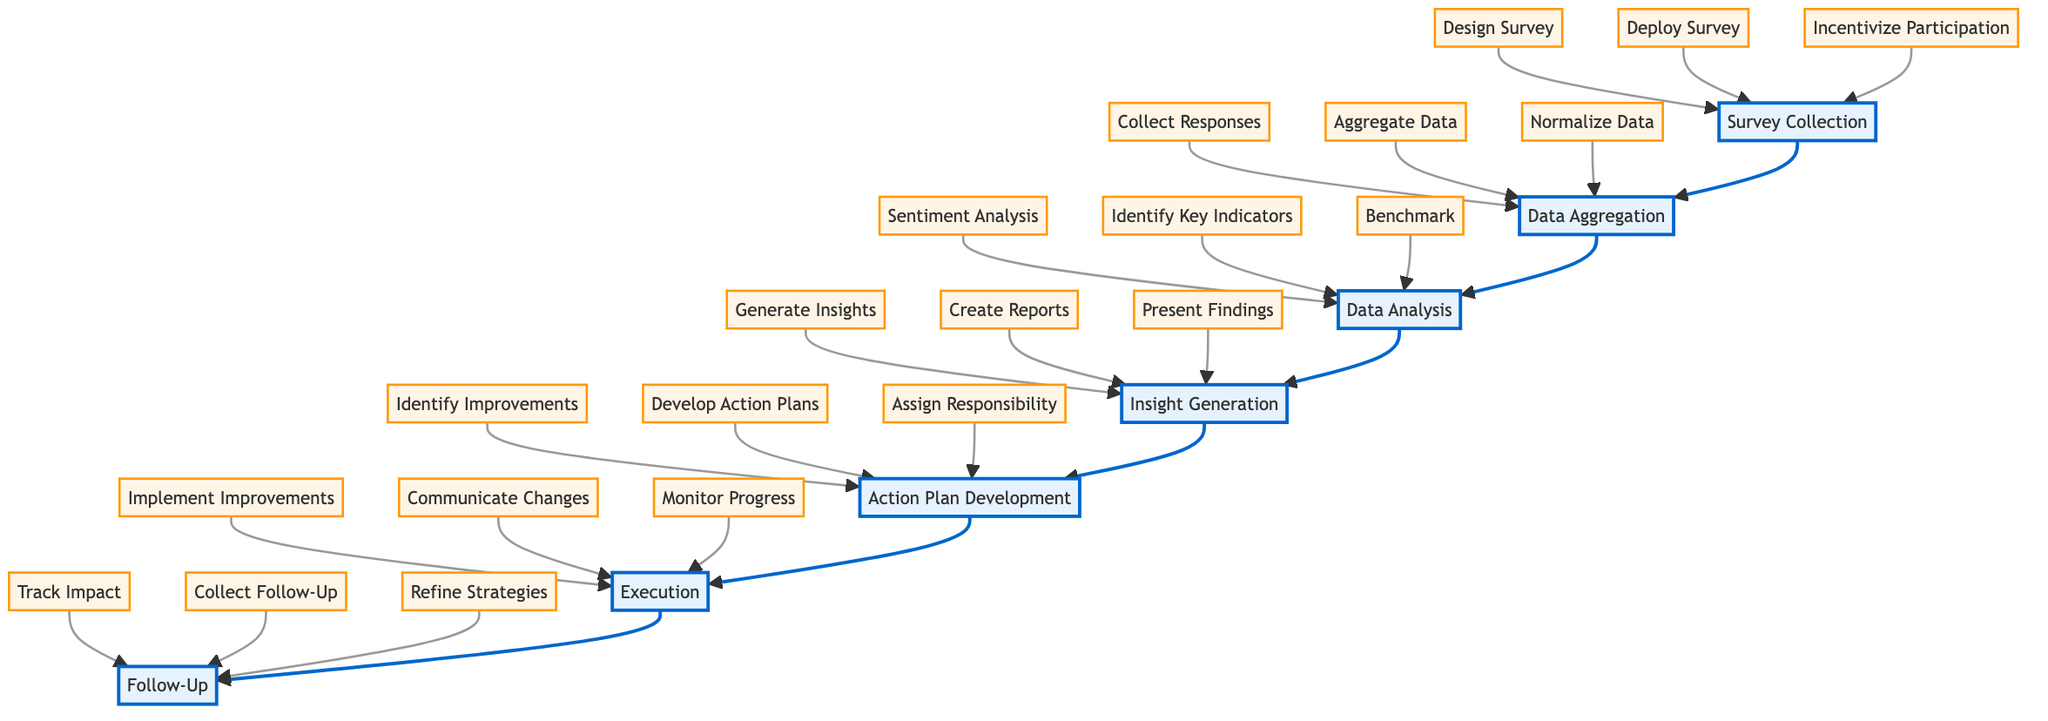What is the first step in the Tenant Satisfaction Improvement process? The diagram indicates that the first step is "Survey Collection," as it is positioned at the bottom of the flow chart and points towards the next step.
Answer: Survey Collection How many components are involved in the "Data Analysis" step? In the diagram, the "Data Analysis" step has three components listed below it: "Perform Sentiment Analysis," "Identify Key Satisfaction Indicators," and "Benchmark Against Industry Standards." Therefore, there are three components.
Answer: 3 What step follows "Insight Generation"? The diagram shows an upward flow where "Insight Generation" is directly connected to "Action Plan Development," indicating that "Action Plan Development" follows "Insight Generation."
Answer: Action Plan Development What action must be taken after insights have been generated? After generating insights, the next required action is to create reports and dashboards and present findings to the management team, which happens in the "Action Plan Development" step. Therefore, we must develop action plans based on the insights generated.
Answer: Develop Action Plans Which step includes monitoring implementation progress? The diagram specifies that the "Execution" step includes monitoring the implementation progress, as it is listed as one of the components under "Execution."
Answer: Execution What is the last step in the Tenant Satisfaction Improvement process? The diagram indicates that the last step is "Follow-Up," which is positioned at the top of the flowchart, indicating it is the final part of the process.
Answer: Follow-Up What is the total number of steps in the Tenant Satisfaction Improvement process? By counting all the distinct steps listed in the diagram from "Survey Collection" to "Follow-Up," we find there are a total of seven steps in the process.
Answer: 7 Which step is responsible for assigning responsibility and deadlines? The "Action Plan Development" step is responsible for assigning responsibility and deadlines, as indicated by the corresponding component beneath it in the diagram.
Answer: Action Plan Development Which step must take place immediately after data aggregation? The diagram shows that "Data Analysis" must occur immediately after "Data Aggregation," as indicated by the flow from one to the next.
Answer: Data Analysis 